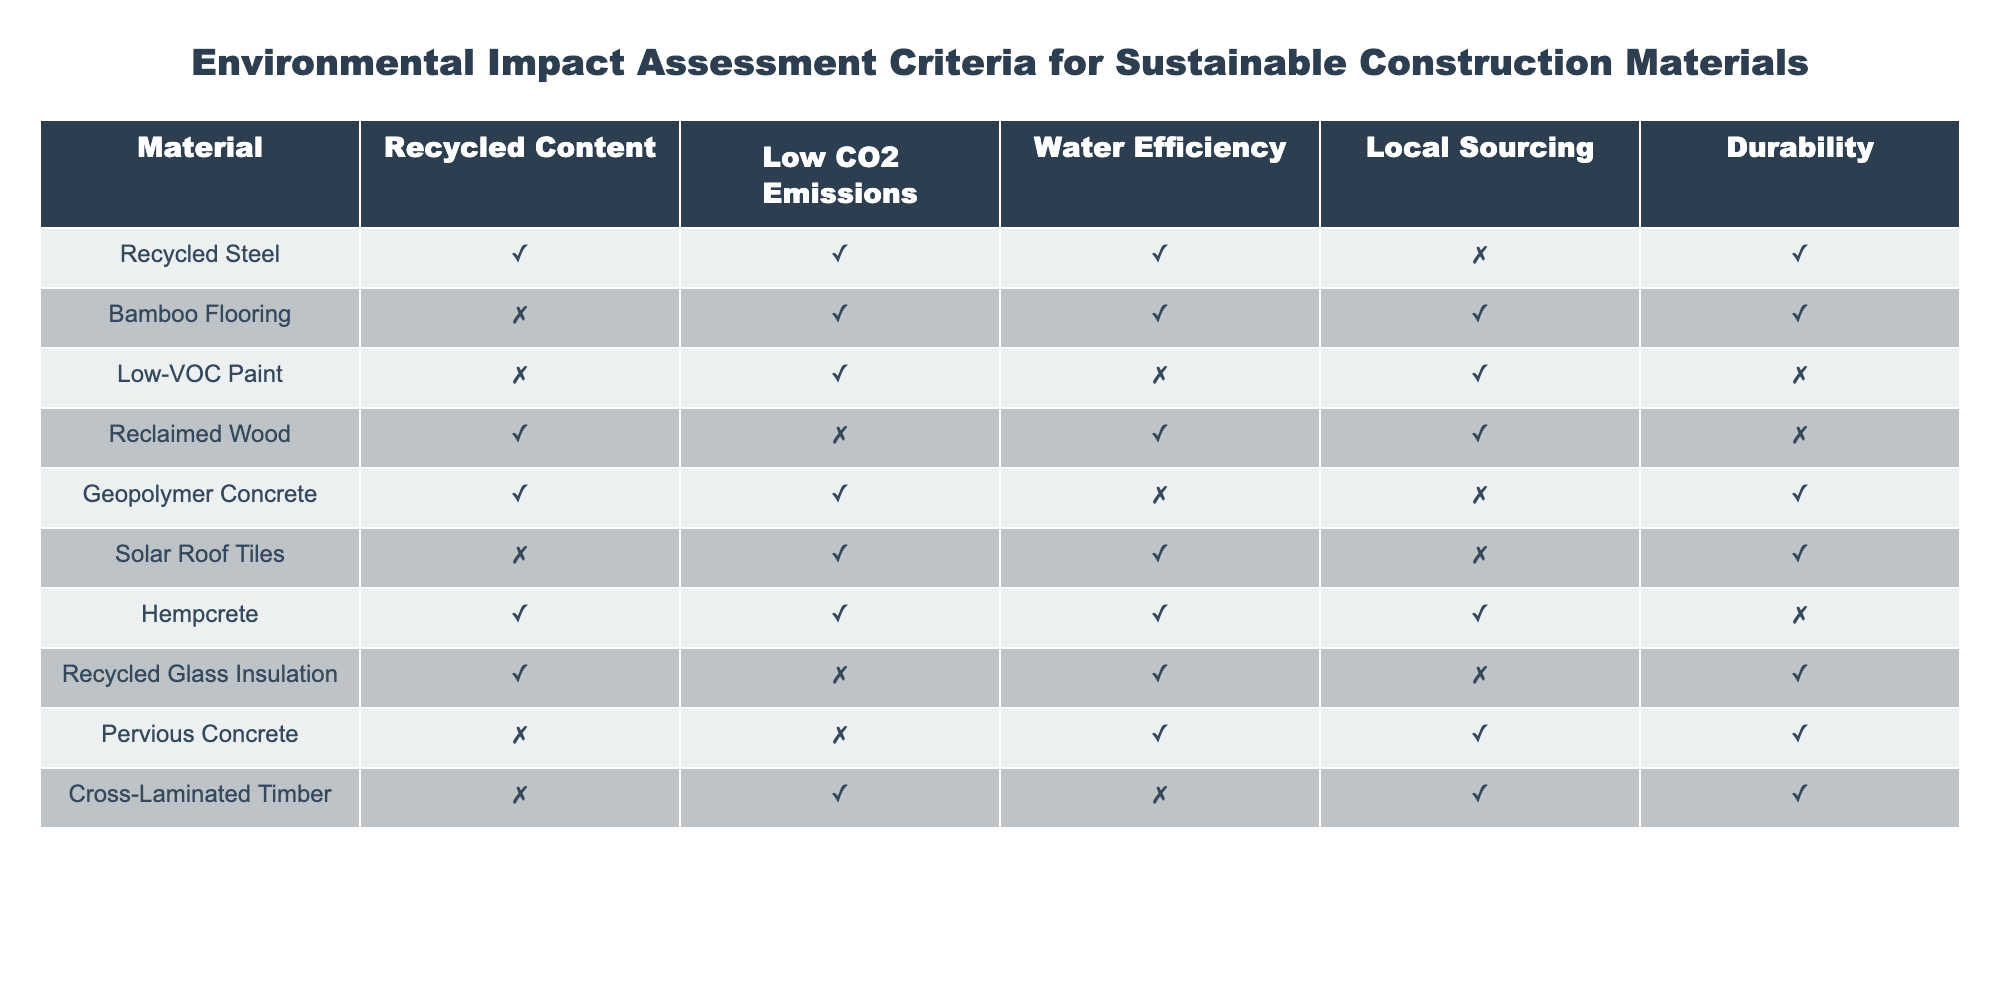What material has the highest durability? From the table, I observe the durability values for each material. The materials with the highest durability (TRUE) are Recycled Steel, Bamboo Flooring, Hempcrete, Pervious Concrete, and Cross-Laminated Timber. Among these, Recycled Steel is the first one listed; however, to denote the highest durability, it would simply be any of these.
Answer: Recycled Steel Which material has low CO2 emissions and durability but does not have recycled content? I look at the Low CO2 Emissions and Durability criteria in the table. The materials that meet Low CO2 Emissions are Bamboo Flooring, Low-VOC Paint, Solar Roof Tiles, and Cross-Laminated Timber. Of these, only Cross-Laminated Timber has high durability (TRUE) and does not have recycled content (it’s FALSE).
Answer: Cross-Laminated Timber How many materials are locally sourced and have water efficiency? I scan the Local Sourcing and Water Efficiency columns. The locally sourced materials (TRUE) that also have water efficiency (TRUE) are Bamboo Flooring, Reclaimed Wood, and Hempcrete. Counting these gives a total of 3 materials.
Answer: 3 Is there any material that achieves all assessment criteria? I check the criterion columns for each material, focusing on entries that have TRUE for Recycled Content, Low CO2 Emissions, Water Efficiency, Local Sourcing, and Durability. In the table, no material meets all these criteria; Hempcrete comes close but is missing durability.
Answer: No What is the total number of materials that have high water efficiency? I look at the Water Efficiency column to identify materials marked as TRUE. The materials that have high water efficiency are Recycled Steel, Bamboo Flooring, Reclaimed Wood, Hempcrete, Pervious Concrete, and Cross-Laminated Timber. Counting these gives a total of 6 materials.
Answer: 6 